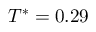Convert formula to latex. <formula><loc_0><loc_0><loc_500><loc_500>T ^ { * } = 0 . 2 9</formula> 